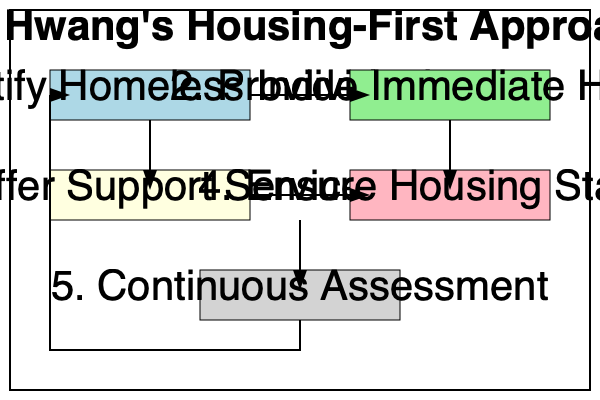According to the flow chart of Dr. Hwang's housing-first approach, what is the step that directly follows "Provide Immediate Housing"? To answer this question, we need to follow the steps in Dr. Hwang's housing-first approach as shown in the flow chart:

1. The process starts with "Identify Homeless Individual" in the top-left box.
2. An arrow leads to "Provide Immediate Housing" in the top-right box.
3. From "Provide Immediate Housing," we see an arrow pointing downward to the next step.
4. This arrow leads to "Offer Support Services" in the box directly below.
5. Therefore, the step that directly follows "Provide Immediate Housing" is "Offer Support Services."

It's important to note that this approach prioritizes providing housing first, before addressing other needs. This is a key principle of the housing-first model, which recognizes that having a stable living situation is fundamental to addressing other issues a homeless person may face.
Answer: Offer Support Services 